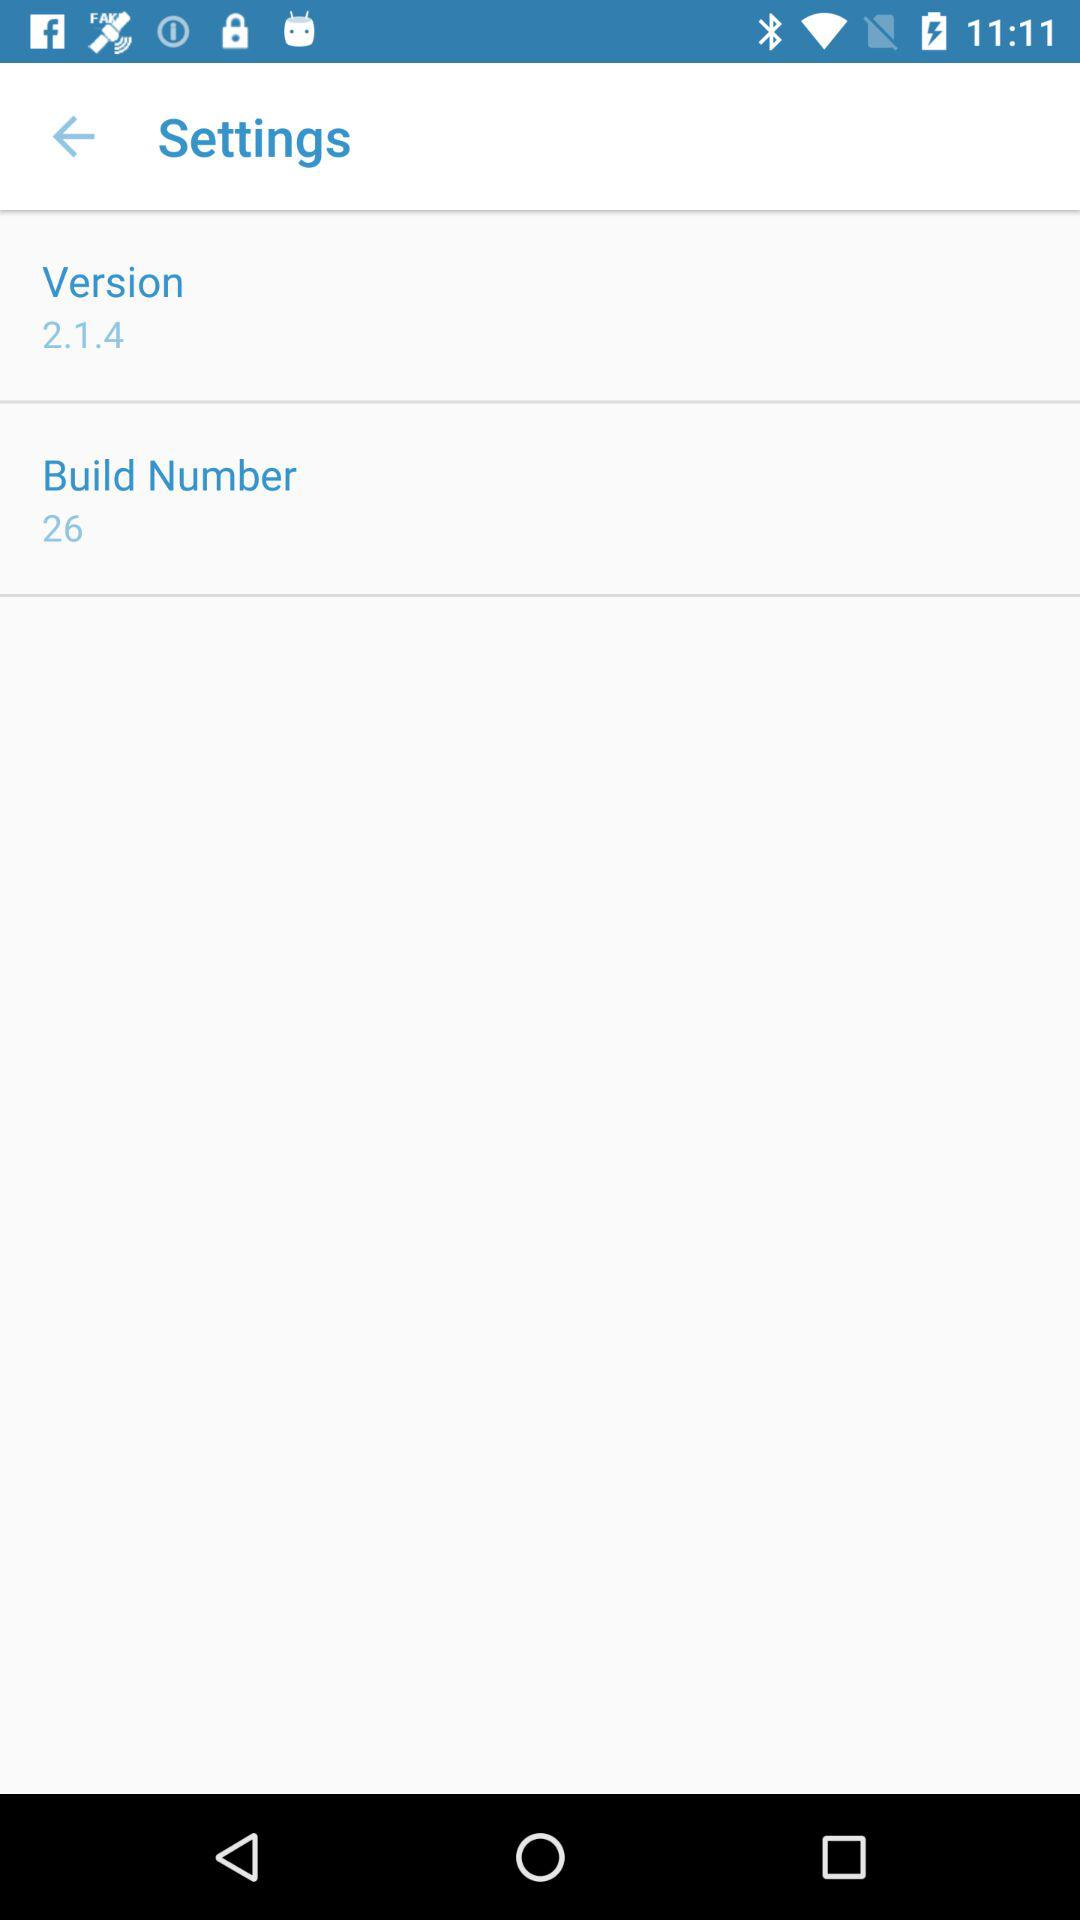What is the version? The version is 2.1.4. 